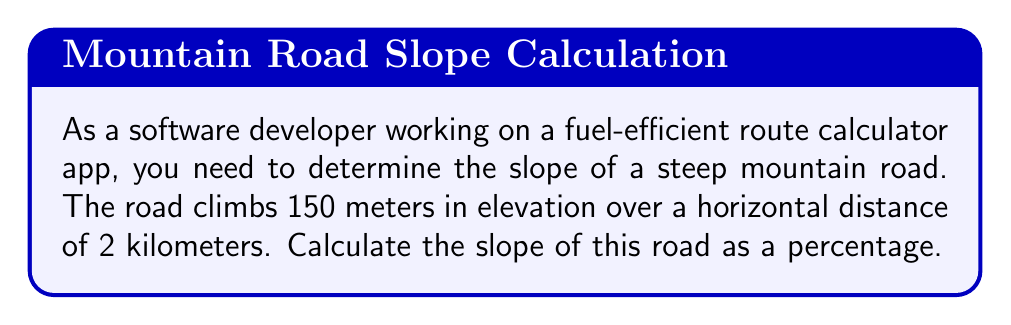Show me your answer to this math problem. To solve this problem, we'll follow these steps:

1. Understand the given information:
   - Elevation change (rise) = 150 meters
   - Horizontal distance (run) = 2 kilometers = 2000 meters

2. Recall the formula for slope:
   $$ \text{Slope} = \frac{\text{Rise}}{\text{Run}} $$

3. Substitute the values into the formula:
   $$ \text{Slope} = \frac{150 \text{ m}}{2000 \text{ m}} = 0.075 $$

4. Convert the decimal to a percentage by multiplying by 100:
   $$ 0.075 \times 100 = 7.5\% $$

The slope of the road is 7.5%, which means for every 100 meters of horizontal distance, the road rises 7.5 meters in elevation.

This information is crucial for your fuel-efficient route calculator app, as steeper slopes generally require more fuel consumption. Your app can use this data to suggest routes that balance distance and elevation changes for optimal fuel efficiency.
Answer: The slope of the road is $7.5\%$. 